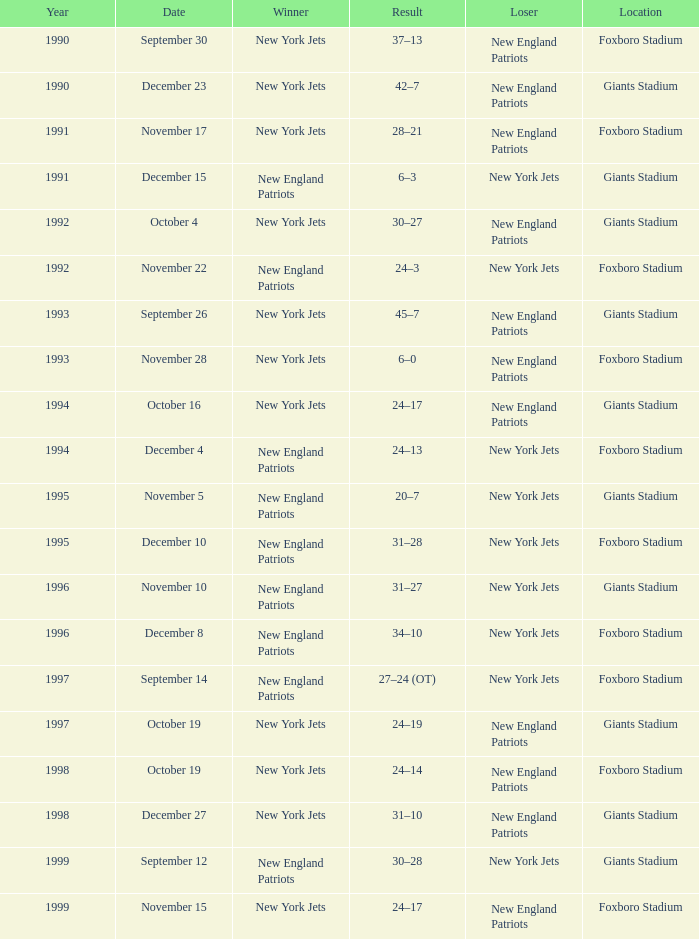What is the name of the Loser when the winner was new england patriots, and a Location of giants stadium, and a Result of 30–28? New York Jets. 